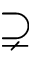Convert formula to latex. <formula><loc_0><loc_0><loc_500><loc_500>\supsetneq</formula> 